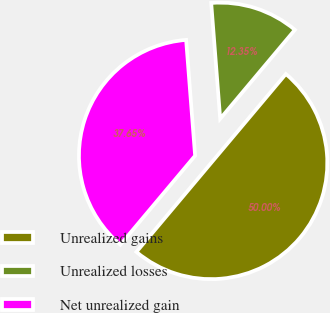Convert chart to OTSL. <chart><loc_0><loc_0><loc_500><loc_500><pie_chart><fcel>Unrealized gains<fcel>Unrealized losses<fcel>Net unrealized gain<nl><fcel>50.0%<fcel>12.35%<fcel>37.65%<nl></chart> 